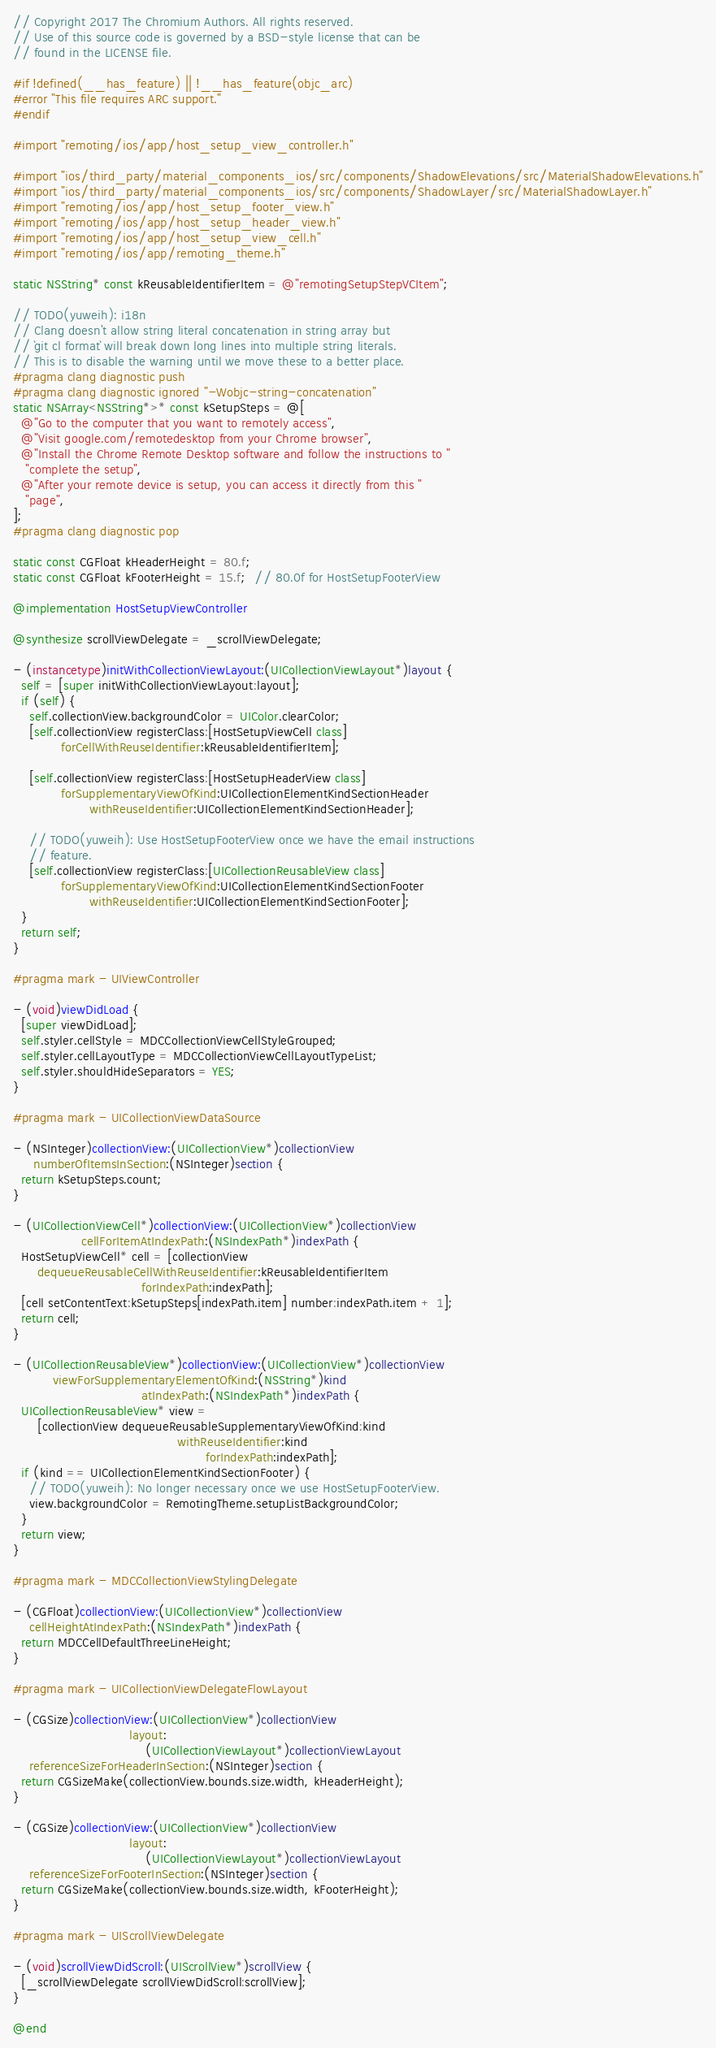Convert code to text. <code><loc_0><loc_0><loc_500><loc_500><_ObjectiveC_>// Copyright 2017 The Chromium Authors. All rights reserved.
// Use of this source code is governed by a BSD-style license that can be
// found in the LICENSE file.

#if !defined(__has_feature) || !__has_feature(objc_arc)
#error "This file requires ARC support."
#endif

#import "remoting/ios/app/host_setup_view_controller.h"

#import "ios/third_party/material_components_ios/src/components/ShadowElevations/src/MaterialShadowElevations.h"
#import "ios/third_party/material_components_ios/src/components/ShadowLayer/src/MaterialShadowLayer.h"
#import "remoting/ios/app/host_setup_footer_view.h"
#import "remoting/ios/app/host_setup_header_view.h"
#import "remoting/ios/app/host_setup_view_cell.h"
#import "remoting/ios/app/remoting_theme.h"

static NSString* const kReusableIdentifierItem = @"remotingSetupStepVCItem";

// TODO(yuweih): i18n
// Clang doesn't allow string literal concatenation in string array but
// `git cl format` will break down long lines into multiple string literals.
// This is to disable the warning until we move these to a better place.
#pragma clang diagnostic push
#pragma clang diagnostic ignored "-Wobjc-string-concatenation"
static NSArray<NSString*>* const kSetupSteps = @[
  @"Go to the computer that you want to remotely access",
  @"Visit google.com/remotedesktop from your Chrome browser",
  @"Install the Chrome Remote Desktop software and follow the instructions to "
   "complete the setup",
  @"After your remote device is setup, you can access it directly from this "
   "page",
];
#pragma clang diagnostic pop

static const CGFloat kHeaderHeight = 80.f;
static const CGFloat kFooterHeight = 15.f;  // 80.0f for HostSetupFooterView

@implementation HostSetupViewController

@synthesize scrollViewDelegate = _scrollViewDelegate;

- (instancetype)initWithCollectionViewLayout:(UICollectionViewLayout*)layout {
  self = [super initWithCollectionViewLayout:layout];
  if (self) {
    self.collectionView.backgroundColor = UIColor.clearColor;
    [self.collectionView registerClass:[HostSetupViewCell class]
            forCellWithReuseIdentifier:kReusableIdentifierItem];

    [self.collectionView registerClass:[HostSetupHeaderView class]
            forSupplementaryViewOfKind:UICollectionElementKindSectionHeader
                   withReuseIdentifier:UICollectionElementKindSectionHeader];

    // TODO(yuweih): Use HostSetupFooterView once we have the email instructions
    // feature.
    [self.collectionView registerClass:[UICollectionReusableView class]
            forSupplementaryViewOfKind:UICollectionElementKindSectionFooter
                   withReuseIdentifier:UICollectionElementKindSectionFooter];
  }
  return self;
}

#pragma mark - UIViewController

- (void)viewDidLoad {
  [super viewDidLoad];
  self.styler.cellStyle = MDCCollectionViewCellStyleGrouped;
  self.styler.cellLayoutType = MDCCollectionViewCellLayoutTypeList;
  self.styler.shouldHideSeparators = YES;
}

#pragma mark - UICollectionViewDataSource

- (NSInteger)collectionView:(UICollectionView*)collectionView
     numberOfItemsInSection:(NSInteger)section {
  return kSetupSteps.count;
}

- (UICollectionViewCell*)collectionView:(UICollectionView*)collectionView
                 cellForItemAtIndexPath:(NSIndexPath*)indexPath {
  HostSetupViewCell* cell = [collectionView
      dequeueReusableCellWithReuseIdentifier:kReusableIdentifierItem
                                forIndexPath:indexPath];
  [cell setContentText:kSetupSteps[indexPath.item] number:indexPath.item + 1];
  return cell;
}

- (UICollectionReusableView*)collectionView:(UICollectionView*)collectionView
          viewForSupplementaryElementOfKind:(NSString*)kind
                                atIndexPath:(NSIndexPath*)indexPath {
  UICollectionReusableView* view =
      [collectionView dequeueReusableSupplementaryViewOfKind:kind
                                         withReuseIdentifier:kind
                                                forIndexPath:indexPath];
  if (kind == UICollectionElementKindSectionFooter) {
    // TODO(yuweih): No longer necessary once we use HostSetupFooterView.
    view.backgroundColor = RemotingTheme.setupListBackgroundColor;
  }
  return view;
}

#pragma mark - MDCCollectionViewStylingDelegate

- (CGFloat)collectionView:(UICollectionView*)collectionView
    cellHeightAtIndexPath:(NSIndexPath*)indexPath {
  return MDCCellDefaultThreeLineHeight;
}

#pragma mark - UICollectionViewDelegateFlowLayout

- (CGSize)collectionView:(UICollectionView*)collectionView
                             layout:
                                 (UICollectionViewLayout*)collectionViewLayout
    referenceSizeForHeaderInSection:(NSInteger)section {
  return CGSizeMake(collectionView.bounds.size.width, kHeaderHeight);
}

- (CGSize)collectionView:(UICollectionView*)collectionView
                             layout:
                                 (UICollectionViewLayout*)collectionViewLayout
    referenceSizeForFooterInSection:(NSInteger)section {
  return CGSizeMake(collectionView.bounds.size.width, kFooterHeight);
}

#pragma mark - UIScrollViewDelegate

- (void)scrollViewDidScroll:(UIScrollView*)scrollView {
  [_scrollViewDelegate scrollViewDidScroll:scrollView];
}

@end
</code> 